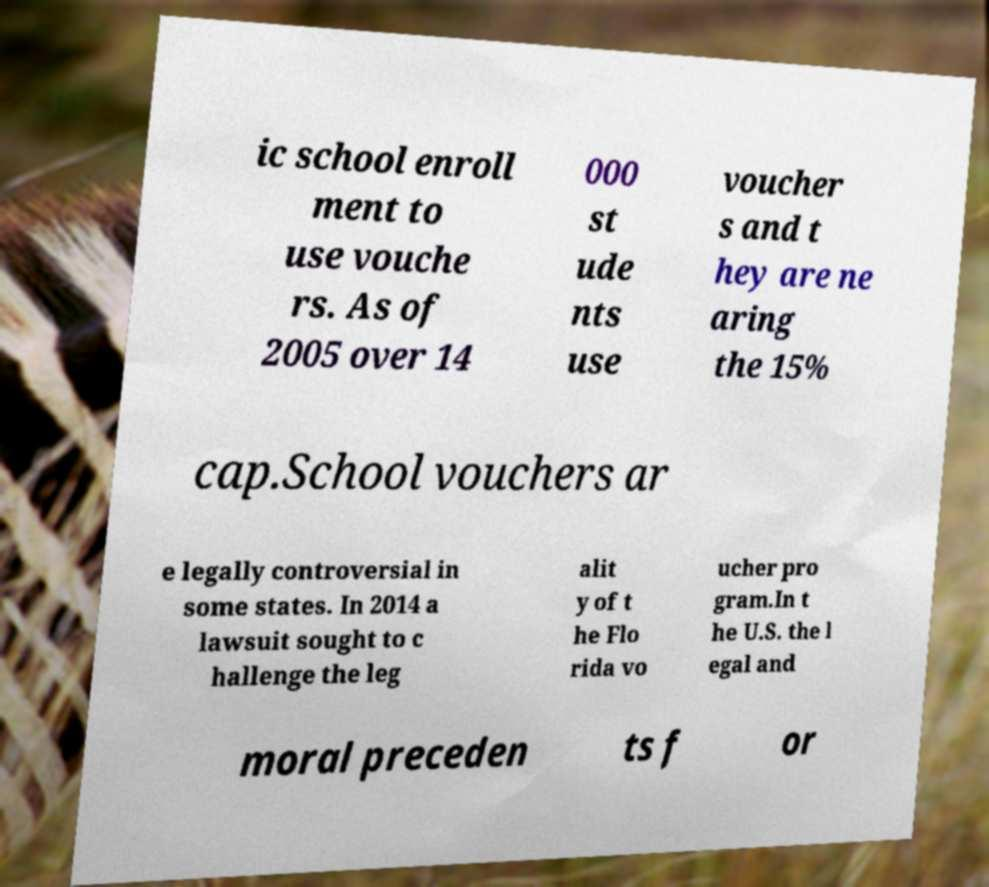Can you read and provide the text displayed in the image?This photo seems to have some interesting text. Can you extract and type it out for me? ic school enroll ment to use vouche rs. As of 2005 over 14 000 st ude nts use voucher s and t hey are ne aring the 15% cap.School vouchers ar e legally controversial in some states. In 2014 a lawsuit sought to c hallenge the leg alit y of t he Flo rida vo ucher pro gram.In t he U.S. the l egal and moral preceden ts f or 